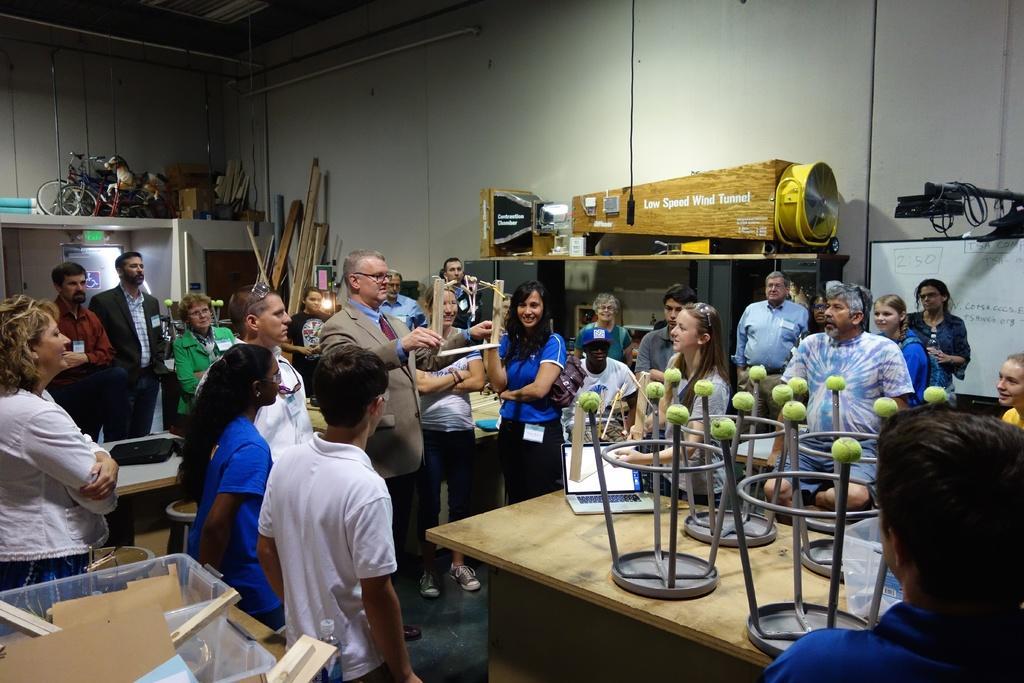Could you give a brief overview of what you see in this image? In the given image we can see that there are many people standing. There is a table on which a stool is kept. This is a room. 